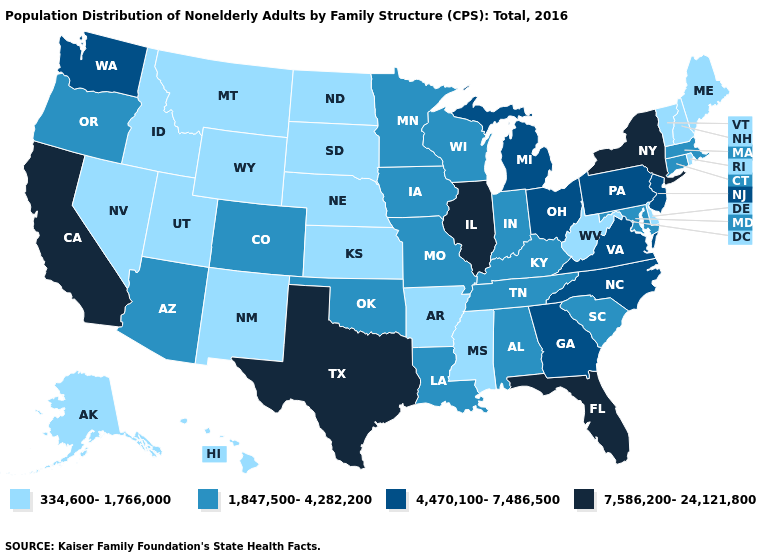Name the states that have a value in the range 4,470,100-7,486,500?
Write a very short answer. Georgia, Michigan, New Jersey, North Carolina, Ohio, Pennsylvania, Virginia, Washington. Does Florida have the highest value in the USA?
Write a very short answer. Yes. What is the lowest value in the MidWest?
Concise answer only. 334,600-1,766,000. What is the lowest value in the USA?
Give a very brief answer. 334,600-1,766,000. Does Illinois have the lowest value in the USA?
Short answer required. No. Name the states that have a value in the range 334,600-1,766,000?
Short answer required. Alaska, Arkansas, Delaware, Hawaii, Idaho, Kansas, Maine, Mississippi, Montana, Nebraska, Nevada, New Hampshire, New Mexico, North Dakota, Rhode Island, South Dakota, Utah, Vermont, West Virginia, Wyoming. Name the states that have a value in the range 4,470,100-7,486,500?
Short answer required. Georgia, Michigan, New Jersey, North Carolina, Ohio, Pennsylvania, Virginia, Washington. Name the states that have a value in the range 334,600-1,766,000?
Quick response, please. Alaska, Arkansas, Delaware, Hawaii, Idaho, Kansas, Maine, Mississippi, Montana, Nebraska, Nevada, New Hampshire, New Mexico, North Dakota, Rhode Island, South Dakota, Utah, Vermont, West Virginia, Wyoming. What is the highest value in the USA?
Write a very short answer. 7,586,200-24,121,800. Does Illinois have the highest value in the MidWest?
Quick response, please. Yes. How many symbols are there in the legend?
Short answer required. 4. What is the lowest value in the Northeast?
Concise answer only. 334,600-1,766,000. Does Massachusetts have the lowest value in the USA?
Write a very short answer. No. What is the lowest value in the MidWest?
Answer briefly. 334,600-1,766,000. Does the first symbol in the legend represent the smallest category?
Short answer required. Yes. 